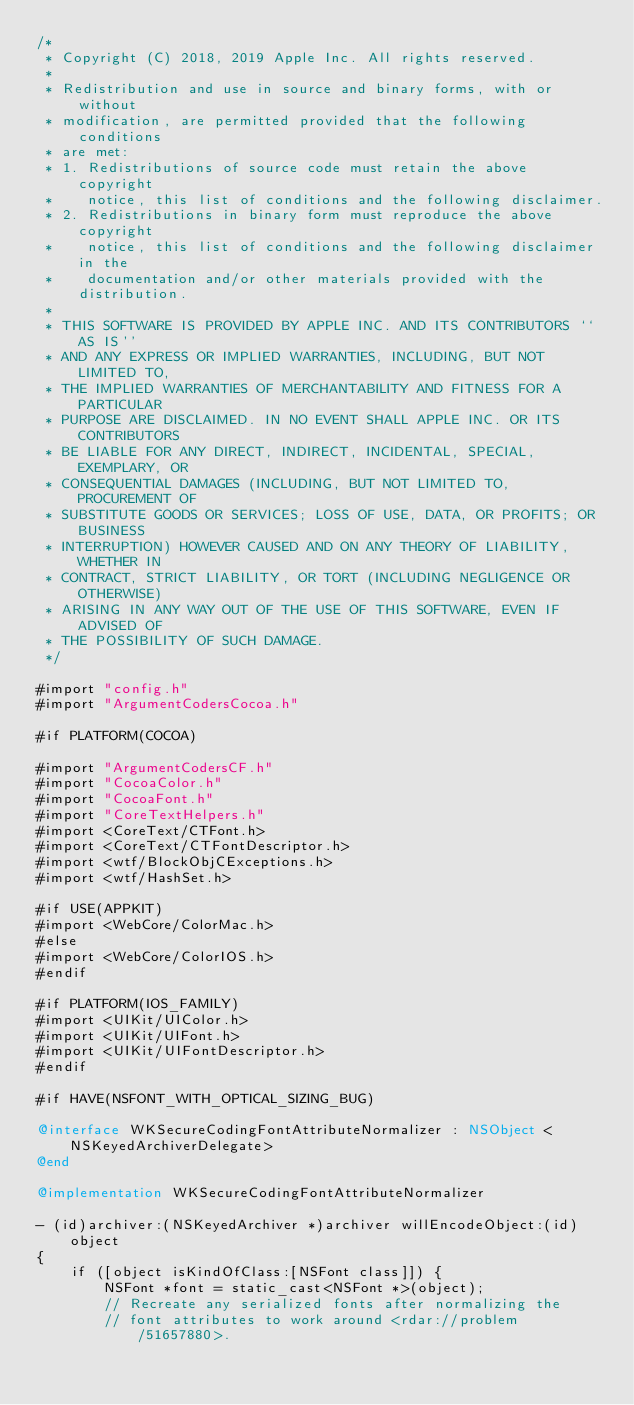<code> <loc_0><loc_0><loc_500><loc_500><_ObjectiveC_>/*
 * Copyright (C) 2018, 2019 Apple Inc. All rights reserved.
 *
 * Redistribution and use in source and binary forms, with or without
 * modification, are permitted provided that the following conditions
 * are met:
 * 1. Redistributions of source code must retain the above copyright
 *    notice, this list of conditions and the following disclaimer.
 * 2. Redistributions in binary form must reproduce the above copyright
 *    notice, this list of conditions and the following disclaimer in the
 *    documentation and/or other materials provided with the distribution.
 *
 * THIS SOFTWARE IS PROVIDED BY APPLE INC. AND ITS CONTRIBUTORS ``AS IS''
 * AND ANY EXPRESS OR IMPLIED WARRANTIES, INCLUDING, BUT NOT LIMITED TO,
 * THE IMPLIED WARRANTIES OF MERCHANTABILITY AND FITNESS FOR A PARTICULAR
 * PURPOSE ARE DISCLAIMED. IN NO EVENT SHALL APPLE INC. OR ITS CONTRIBUTORS
 * BE LIABLE FOR ANY DIRECT, INDIRECT, INCIDENTAL, SPECIAL, EXEMPLARY, OR
 * CONSEQUENTIAL DAMAGES (INCLUDING, BUT NOT LIMITED TO, PROCUREMENT OF
 * SUBSTITUTE GOODS OR SERVICES; LOSS OF USE, DATA, OR PROFITS; OR BUSINESS
 * INTERRUPTION) HOWEVER CAUSED AND ON ANY THEORY OF LIABILITY, WHETHER IN
 * CONTRACT, STRICT LIABILITY, OR TORT (INCLUDING NEGLIGENCE OR OTHERWISE)
 * ARISING IN ANY WAY OUT OF THE USE OF THIS SOFTWARE, EVEN IF ADVISED OF
 * THE POSSIBILITY OF SUCH DAMAGE.
 */

#import "config.h"
#import "ArgumentCodersCocoa.h"

#if PLATFORM(COCOA)

#import "ArgumentCodersCF.h"
#import "CocoaColor.h"
#import "CocoaFont.h"
#import "CoreTextHelpers.h"
#import <CoreText/CTFont.h>
#import <CoreText/CTFontDescriptor.h>
#import <wtf/BlockObjCExceptions.h>
#import <wtf/HashSet.h>

#if USE(APPKIT)
#import <WebCore/ColorMac.h>
#else
#import <WebCore/ColorIOS.h>
#endif

#if PLATFORM(IOS_FAMILY)
#import <UIKit/UIColor.h>
#import <UIKit/UIFont.h>
#import <UIKit/UIFontDescriptor.h>
#endif

#if HAVE(NSFONT_WITH_OPTICAL_SIZING_BUG)

@interface WKSecureCodingFontAttributeNormalizer : NSObject <NSKeyedArchiverDelegate>
@end

@implementation WKSecureCodingFontAttributeNormalizer

- (id)archiver:(NSKeyedArchiver *)archiver willEncodeObject:(id)object
{
    if ([object isKindOfClass:[NSFont class]]) {
        NSFont *font = static_cast<NSFont *>(object);
        // Recreate any serialized fonts after normalizing the
        // font attributes to work around <rdar://problem/51657880>.</code> 